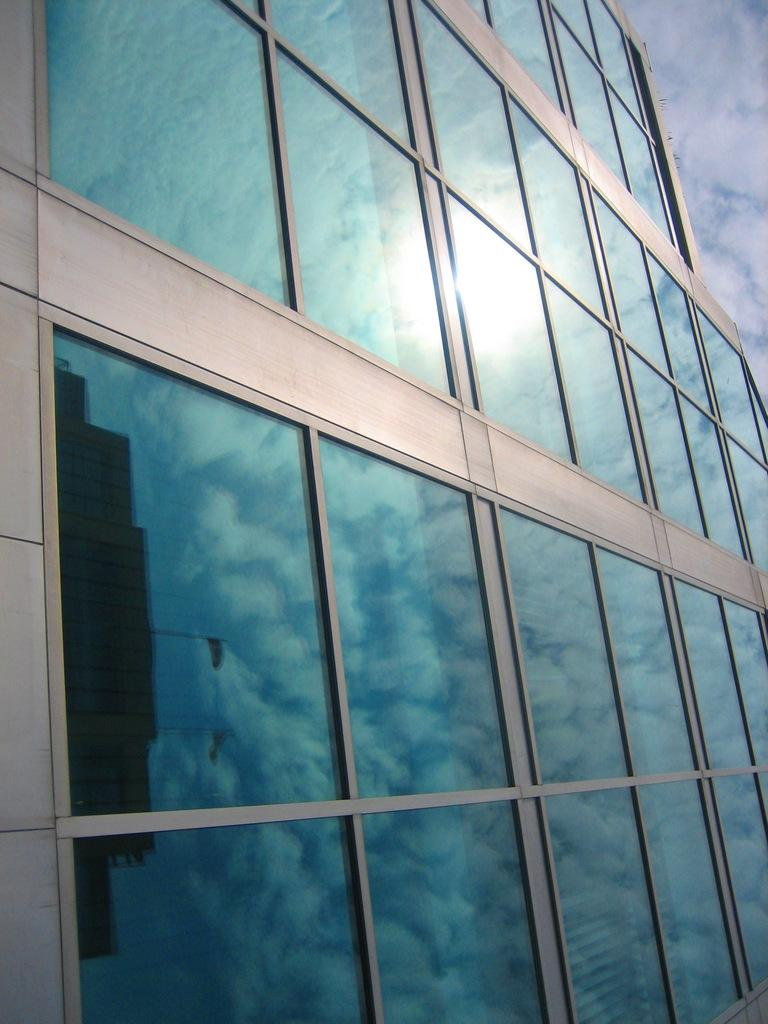What type of structure is present in the image? There is a building in the image. What feature can be observed on the building? The building has glass doors. What can be seen reflected on the glass doors? The reflection of another building and the sky are visible on the glass doors. Where are the beds located in the image? There are no beds present in the image. What type of vegetation can be seen growing on the glass doors? There is no vegetation, such as a twig, present on the glass doors in the image. 